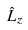<formula> <loc_0><loc_0><loc_500><loc_500>\hat { L } _ { z }</formula> 